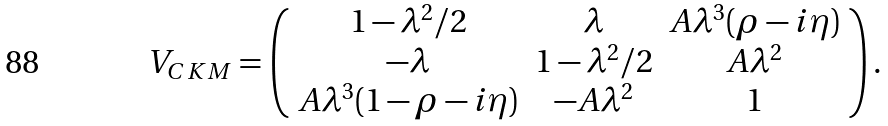<formula> <loc_0><loc_0><loc_500><loc_500>V _ { C K M } = \left ( \begin{array} { c c c } { { 1 - \lambda ^ { 2 } / 2 } } & { \lambda } & { { A \lambda ^ { 3 } ( \rho - i \eta ) } } \\ { - \lambda } & { { 1 - \lambda ^ { 2 } / 2 } } & { { A \lambda ^ { 2 } } } \\ { { A \lambda ^ { 3 } ( 1 - \rho - i \eta ) } } & { { - A \lambda ^ { 2 } } } & { 1 } \end{array} \right ) .</formula> 